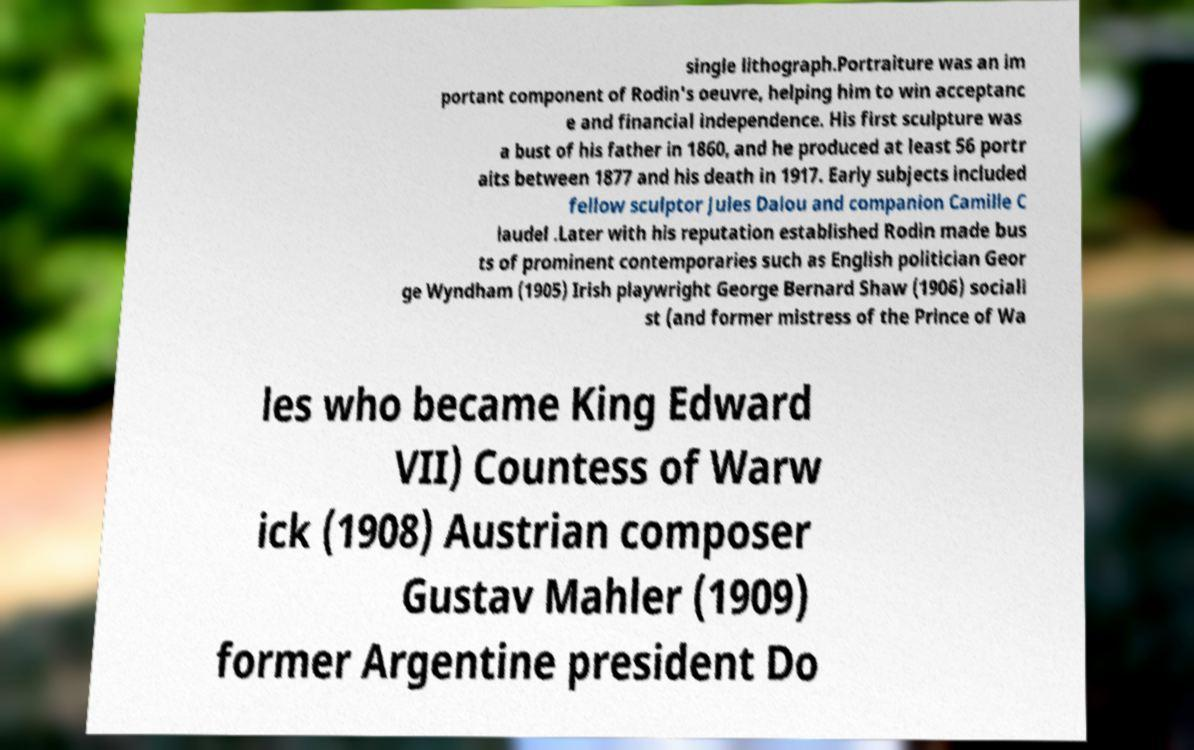Can you accurately transcribe the text from the provided image for me? single lithograph.Portraiture was an im portant component of Rodin's oeuvre, helping him to win acceptanc e and financial independence. His first sculpture was a bust of his father in 1860, and he produced at least 56 portr aits between 1877 and his death in 1917. Early subjects included fellow sculptor Jules Dalou and companion Camille C laudel .Later with his reputation established Rodin made bus ts of prominent contemporaries such as English politician Geor ge Wyndham (1905) Irish playwright George Bernard Shaw (1906) sociali st (and former mistress of the Prince of Wa les who became King Edward VII) Countess of Warw ick (1908) Austrian composer Gustav Mahler (1909) former Argentine president Do 